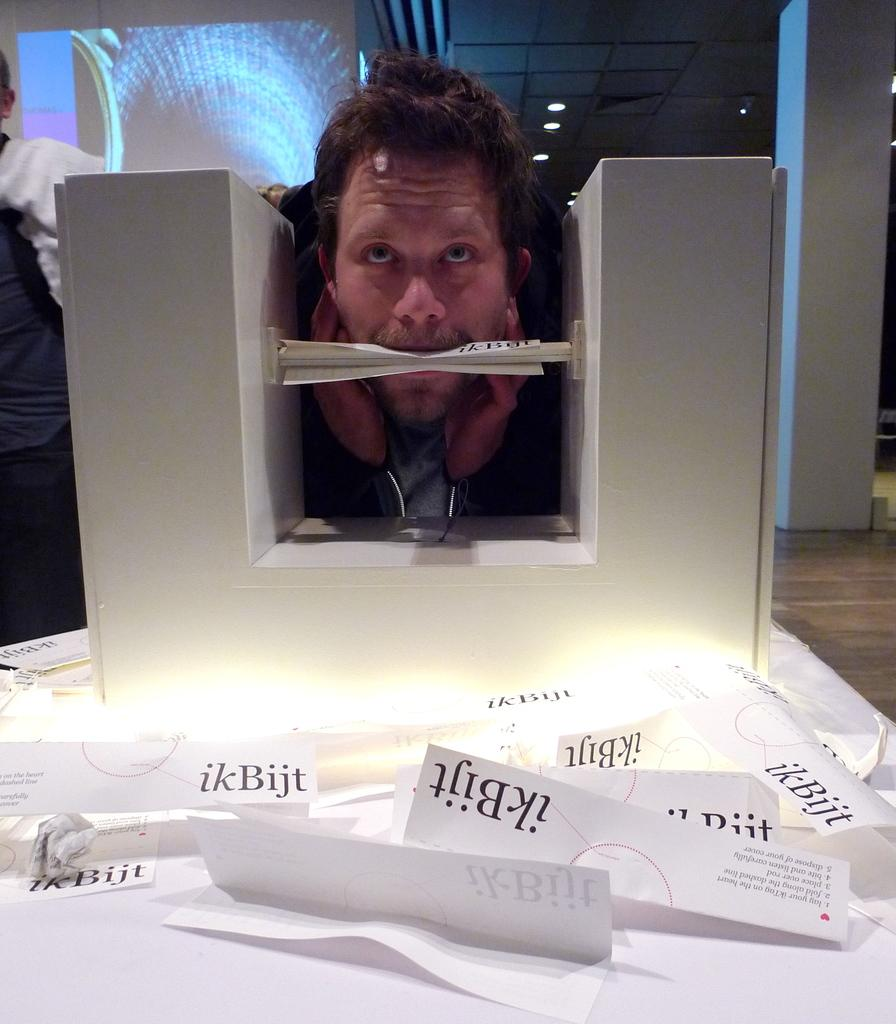<image>
Present a compact description of the photo's key features. Pieces of paper with the logo ikBijt on them are in front of a man with one in his mouth. 